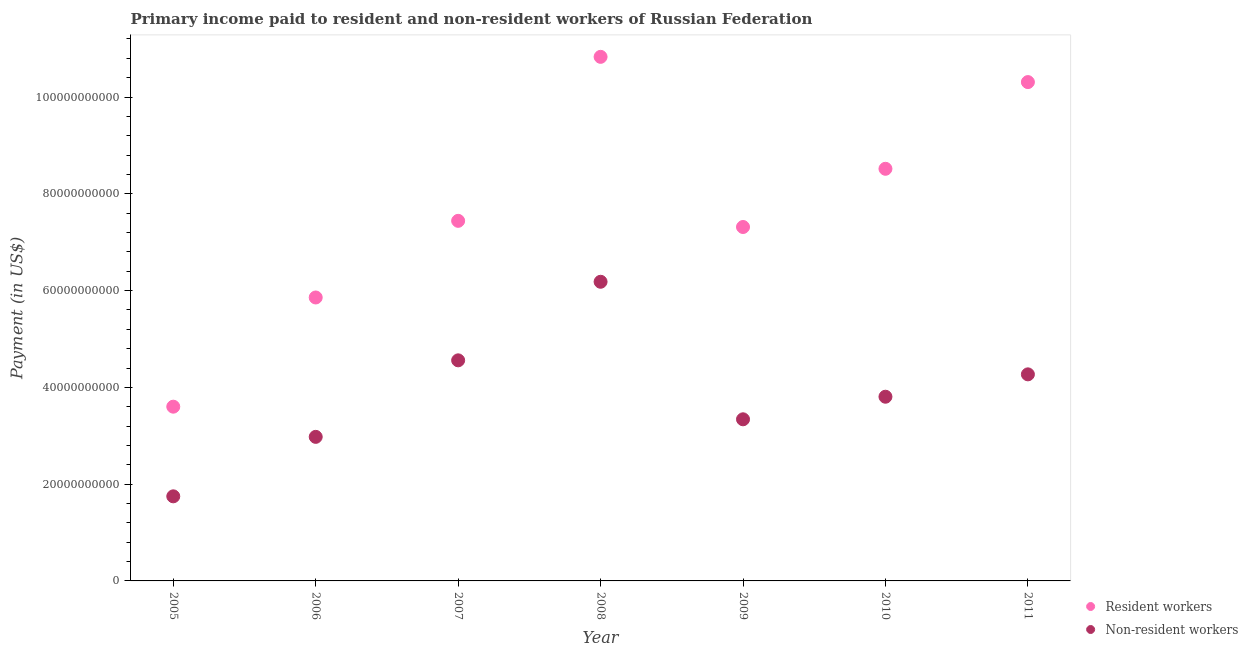Is the number of dotlines equal to the number of legend labels?
Ensure brevity in your answer.  Yes. What is the payment made to resident workers in 2011?
Keep it short and to the point. 1.03e+11. Across all years, what is the maximum payment made to resident workers?
Give a very brief answer. 1.08e+11. Across all years, what is the minimum payment made to non-resident workers?
Ensure brevity in your answer.  1.75e+1. In which year was the payment made to resident workers maximum?
Provide a short and direct response. 2008. What is the total payment made to resident workers in the graph?
Make the answer very short. 5.39e+11. What is the difference between the payment made to non-resident workers in 2006 and that in 2008?
Your answer should be compact. -3.20e+1. What is the difference between the payment made to resident workers in 2010 and the payment made to non-resident workers in 2009?
Give a very brief answer. 5.18e+1. What is the average payment made to non-resident workers per year?
Offer a very short reply. 3.84e+1. In the year 2006, what is the difference between the payment made to resident workers and payment made to non-resident workers?
Keep it short and to the point. 2.88e+1. In how many years, is the payment made to non-resident workers greater than 60000000000 US$?
Make the answer very short. 1. What is the ratio of the payment made to non-resident workers in 2008 to that in 2011?
Your response must be concise. 1.45. Is the payment made to non-resident workers in 2007 less than that in 2009?
Your answer should be compact. No. What is the difference between the highest and the second highest payment made to non-resident workers?
Make the answer very short. 1.62e+1. What is the difference between the highest and the lowest payment made to resident workers?
Offer a very short reply. 7.23e+1. Is the sum of the payment made to non-resident workers in 2010 and 2011 greater than the maximum payment made to resident workers across all years?
Make the answer very short. No. Does the payment made to non-resident workers monotonically increase over the years?
Keep it short and to the point. No. Is the payment made to resident workers strictly greater than the payment made to non-resident workers over the years?
Offer a very short reply. Yes. Are the values on the major ticks of Y-axis written in scientific E-notation?
Your answer should be very brief. No. Does the graph contain any zero values?
Make the answer very short. No. Does the graph contain grids?
Offer a very short reply. No. How are the legend labels stacked?
Provide a short and direct response. Vertical. What is the title of the graph?
Keep it short and to the point. Primary income paid to resident and non-resident workers of Russian Federation. Does "Banks" appear as one of the legend labels in the graph?
Your answer should be very brief. No. What is the label or title of the Y-axis?
Your answer should be very brief. Payment (in US$). What is the Payment (in US$) of Resident workers in 2005?
Make the answer very short. 3.60e+1. What is the Payment (in US$) of Non-resident workers in 2005?
Provide a short and direct response. 1.75e+1. What is the Payment (in US$) in Resident workers in 2006?
Make the answer very short. 5.86e+1. What is the Payment (in US$) in Non-resident workers in 2006?
Your answer should be very brief. 2.98e+1. What is the Payment (in US$) in Resident workers in 2007?
Your answer should be compact. 7.44e+1. What is the Payment (in US$) of Non-resident workers in 2007?
Offer a terse response. 4.56e+1. What is the Payment (in US$) of Resident workers in 2008?
Your answer should be compact. 1.08e+11. What is the Payment (in US$) in Non-resident workers in 2008?
Your response must be concise. 6.18e+1. What is the Payment (in US$) of Resident workers in 2009?
Keep it short and to the point. 7.31e+1. What is the Payment (in US$) in Non-resident workers in 2009?
Your answer should be compact. 3.34e+1. What is the Payment (in US$) of Resident workers in 2010?
Offer a very short reply. 8.52e+1. What is the Payment (in US$) in Non-resident workers in 2010?
Give a very brief answer. 3.81e+1. What is the Payment (in US$) of Resident workers in 2011?
Give a very brief answer. 1.03e+11. What is the Payment (in US$) of Non-resident workers in 2011?
Ensure brevity in your answer.  4.27e+1. Across all years, what is the maximum Payment (in US$) in Resident workers?
Make the answer very short. 1.08e+11. Across all years, what is the maximum Payment (in US$) in Non-resident workers?
Your answer should be compact. 6.18e+1. Across all years, what is the minimum Payment (in US$) of Resident workers?
Offer a terse response. 3.60e+1. Across all years, what is the minimum Payment (in US$) in Non-resident workers?
Your answer should be compact. 1.75e+1. What is the total Payment (in US$) in Resident workers in the graph?
Make the answer very short. 5.39e+11. What is the total Payment (in US$) of Non-resident workers in the graph?
Make the answer very short. 2.69e+11. What is the difference between the Payment (in US$) in Resident workers in 2005 and that in 2006?
Ensure brevity in your answer.  -2.26e+1. What is the difference between the Payment (in US$) in Non-resident workers in 2005 and that in 2006?
Offer a very short reply. -1.23e+1. What is the difference between the Payment (in US$) of Resident workers in 2005 and that in 2007?
Make the answer very short. -3.84e+1. What is the difference between the Payment (in US$) of Non-resident workers in 2005 and that in 2007?
Your answer should be very brief. -2.81e+1. What is the difference between the Payment (in US$) in Resident workers in 2005 and that in 2008?
Provide a succinct answer. -7.23e+1. What is the difference between the Payment (in US$) in Non-resident workers in 2005 and that in 2008?
Keep it short and to the point. -4.43e+1. What is the difference between the Payment (in US$) in Resident workers in 2005 and that in 2009?
Provide a succinct answer. -3.71e+1. What is the difference between the Payment (in US$) of Non-resident workers in 2005 and that in 2009?
Make the answer very short. -1.59e+1. What is the difference between the Payment (in US$) in Resident workers in 2005 and that in 2010?
Give a very brief answer. -4.92e+1. What is the difference between the Payment (in US$) in Non-resident workers in 2005 and that in 2010?
Your answer should be very brief. -2.06e+1. What is the difference between the Payment (in US$) of Resident workers in 2005 and that in 2011?
Provide a succinct answer. -6.71e+1. What is the difference between the Payment (in US$) of Non-resident workers in 2005 and that in 2011?
Offer a very short reply. -2.52e+1. What is the difference between the Payment (in US$) of Resident workers in 2006 and that in 2007?
Provide a succinct answer. -1.58e+1. What is the difference between the Payment (in US$) of Non-resident workers in 2006 and that in 2007?
Keep it short and to the point. -1.58e+1. What is the difference between the Payment (in US$) in Resident workers in 2006 and that in 2008?
Provide a succinct answer. -4.97e+1. What is the difference between the Payment (in US$) of Non-resident workers in 2006 and that in 2008?
Your response must be concise. -3.20e+1. What is the difference between the Payment (in US$) in Resident workers in 2006 and that in 2009?
Give a very brief answer. -1.46e+1. What is the difference between the Payment (in US$) of Non-resident workers in 2006 and that in 2009?
Ensure brevity in your answer.  -3.63e+09. What is the difference between the Payment (in US$) in Resident workers in 2006 and that in 2010?
Your response must be concise. -2.66e+1. What is the difference between the Payment (in US$) in Non-resident workers in 2006 and that in 2010?
Make the answer very short. -8.29e+09. What is the difference between the Payment (in US$) of Resident workers in 2006 and that in 2011?
Provide a succinct answer. -4.45e+1. What is the difference between the Payment (in US$) of Non-resident workers in 2006 and that in 2011?
Make the answer very short. -1.29e+1. What is the difference between the Payment (in US$) in Resident workers in 2007 and that in 2008?
Your answer should be compact. -3.39e+1. What is the difference between the Payment (in US$) in Non-resident workers in 2007 and that in 2008?
Keep it short and to the point. -1.62e+1. What is the difference between the Payment (in US$) in Resident workers in 2007 and that in 2009?
Offer a very short reply. 1.27e+09. What is the difference between the Payment (in US$) of Non-resident workers in 2007 and that in 2009?
Provide a short and direct response. 1.22e+1. What is the difference between the Payment (in US$) of Resident workers in 2007 and that in 2010?
Offer a terse response. -1.08e+1. What is the difference between the Payment (in US$) of Non-resident workers in 2007 and that in 2010?
Your answer should be very brief. 7.52e+09. What is the difference between the Payment (in US$) of Resident workers in 2007 and that in 2011?
Keep it short and to the point. -2.87e+1. What is the difference between the Payment (in US$) in Non-resident workers in 2007 and that in 2011?
Provide a succinct answer. 2.90e+09. What is the difference between the Payment (in US$) of Resident workers in 2008 and that in 2009?
Ensure brevity in your answer.  3.52e+1. What is the difference between the Payment (in US$) of Non-resident workers in 2008 and that in 2009?
Ensure brevity in your answer.  2.84e+1. What is the difference between the Payment (in US$) in Resident workers in 2008 and that in 2010?
Make the answer very short. 2.31e+1. What is the difference between the Payment (in US$) in Non-resident workers in 2008 and that in 2010?
Offer a terse response. 2.38e+1. What is the difference between the Payment (in US$) of Resident workers in 2008 and that in 2011?
Provide a succinct answer. 5.22e+09. What is the difference between the Payment (in US$) of Non-resident workers in 2008 and that in 2011?
Make the answer very short. 1.91e+1. What is the difference between the Payment (in US$) of Resident workers in 2009 and that in 2010?
Your answer should be very brief. -1.20e+1. What is the difference between the Payment (in US$) of Non-resident workers in 2009 and that in 2010?
Provide a short and direct response. -4.66e+09. What is the difference between the Payment (in US$) of Resident workers in 2009 and that in 2011?
Provide a succinct answer. -2.99e+1. What is the difference between the Payment (in US$) of Non-resident workers in 2009 and that in 2011?
Provide a succinct answer. -9.29e+09. What is the difference between the Payment (in US$) of Resident workers in 2010 and that in 2011?
Provide a succinct answer. -1.79e+1. What is the difference between the Payment (in US$) of Non-resident workers in 2010 and that in 2011?
Give a very brief answer. -4.62e+09. What is the difference between the Payment (in US$) of Resident workers in 2005 and the Payment (in US$) of Non-resident workers in 2006?
Your answer should be compact. 6.24e+09. What is the difference between the Payment (in US$) of Resident workers in 2005 and the Payment (in US$) of Non-resident workers in 2007?
Provide a short and direct response. -9.58e+09. What is the difference between the Payment (in US$) of Resident workers in 2005 and the Payment (in US$) of Non-resident workers in 2008?
Offer a terse response. -2.58e+1. What is the difference between the Payment (in US$) in Resident workers in 2005 and the Payment (in US$) in Non-resident workers in 2009?
Give a very brief answer. 2.61e+09. What is the difference between the Payment (in US$) of Resident workers in 2005 and the Payment (in US$) of Non-resident workers in 2010?
Give a very brief answer. -2.06e+09. What is the difference between the Payment (in US$) of Resident workers in 2005 and the Payment (in US$) of Non-resident workers in 2011?
Make the answer very short. -6.68e+09. What is the difference between the Payment (in US$) of Resident workers in 2006 and the Payment (in US$) of Non-resident workers in 2007?
Make the answer very short. 1.30e+1. What is the difference between the Payment (in US$) in Resident workers in 2006 and the Payment (in US$) in Non-resident workers in 2008?
Offer a terse response. -3.25e+09. What is the difference between the Payment (in US$) of Resident workers in 2006 and the Payment (in US$) of Non-resident workers in 2009?
Your answer should be very brief. 2.52e+1. What is the difference between the Payment (in US$) of Resident workers in 2006 and the Payment (in US$) of Non-resident workers in 2010?
Your response must be concise. 2.05e+1. What is the difference between the Payment (in US$) of Resident workers in 2006 and the Payment (in US$) of Non-resident workers in 2011?
Give a very brief answer. 1.59e+1. What is the difference between the Payment (in US$) in Resident workers in 2007 and the Payment (in US$) in Non-resident workers in 2008?
Provide a succinct answer. 1.26e+1. What is the difference between the Payment (in US$) of Resident workers in 2007 and the Payment (in US$) of Non-resident workers in 2009?
Offer a very short reply. 4.10e+1. What is the difference between the Payment (in US$) in Resident workers in 2007 and the Payment (in US$) in Non-resident workers in 2010?
Ensure brevity in your answer.  3.63e+1. What is the difference between the Payment (in US$) of Resident workers in 2007 and the Payment (in US$) of Non-resident workers in 2011?
Your answer should be compact. 3.17e+1. What is the difference between the Payment (in US$) in Resident workers in 2008 and the Payment (in US$) in Non-resident workers in 2009?
Offer a very short reply. 7.49e+1. What is the difference between the Payment (in US$) in Resident workers in 2008 and the Payment (in US$) in Non-resident workers in 2010?
Provide a succinct answer. 7.02e+1. What is the difference between the Payment (in US$) in Resident workers in 2008 and the Payment (in US$) in Non-resident workers in 2011?
Offer a very short reply. 6.56e+1. What is the difference between the Payment (in US$) of Resident workers in 2009 and the Payment (in US$) of Non-resident workers in 2010?
Your response must be concise. 3.51e+1. What is the difference between the Payment (in US$) of Resident workers in 2009 and the Payment (in US$) of Non-resident workers in 2011?
Keep it short and to the point. 3.05e+1. What is the difference between the Payment (in US$) in Resident workers in 2010 and the Payment (in US$) in Non-resident workers in 2011?
Your response must be concise. 4.25e+1. What is the average Payment (in US$) in Resident workers per year?
Keep it short and to the point. 7.70e+1. What is the average Payment (in US$) of Non-resident workers per year?
Provide a succinct answer. 3.84e+1. In the year 2005, what is the difference between the Payment (in US$) in Resident workers and Payment (in US$) in Non-resident workers?
Your response must be concise. 1.85e+1. In the year 2006, what is the difference between the Payment (in US$) of Resident workers and Payment (in US$) of Non-resident workers?
Offer a terse response. 2.88e+1. In the year 2007, what is the difference between the Payment (in US$) of Resident workers and Payment (in US$) of Non-resident workers?
Offer a very short reply. 2.88e+1. In the year 2008, what is the difference between the Payment (in US$) in Resident workers and Payment (in US$) in Non-resident workers?
Offer a terse response. 4.65e+1. In the year 2009, what is the difference between the Payment (in US$) of Resident workers and Payment (in US$) of Non-resident workers?
Keep it short and to the point. 3.97e+1. In the year 2010, what is the difference between the Payment (in US$) in Resident workers and Payment (in US$) in Non-resident workers?
Your response must be concise. 4.71e+1. In the year 2011, what is the difference between the Payment (in US$) in Resident workers and Payment (in US$) in Non-resident workers?
Give a very brief answer. 6.04e+1. What is the ratio of the Payment (in US$) of Resident workers in 2005 to that in 2006?
Provide a short and direct response. 0.61. What is the ratio of the Payment (in US$) in Non-resident workers in 2005 to that in 2006?
Ensure brevity in your answer.  0.59. What is the ratio of the Payment (in US$) in Resident workers in 2005 to that in 2007?
Keep it short and to the point. 0.48. What is the ratio of the Payment (in US$) of Non-resident workers in 2005 to that in 2007?
Give a very brief answer. 0.38. What is the ratio of the Payment (in US$) in Resident workers in 2005 to that in 2008?
Give a very brief answer. 0.33. What is the ratio of the Payment (in US$) in Non-resident workers in 2005 to that in 2008?
Make the answer very short. 0.28. What is the ratio of the Payment (in US$) in Resident workers in 2005 to that in 2009?
Offer a terse response. 0.49. What is the ratio of the Payment (in US$) of Non-resident workers in 2005 to that in 2009?
Your response must be concise. 0.52. What is the ratio of the Payment (in US$) in Resident workers in 2005 to that in 2010?
Keep it short and to the point. 0.42. What is the ratio of the Payment (in US$) of Non-resident workers in 2005 to that in 2010?
Provide a short and direct response. 0.46. What is the ratio of the Payment (in US$) in Resident workers in 2005 to that in 2011?
Keep it short and to the point. 0.35. What is the ratio of the Payment (in US$) of Non-resident workers in 2005 to that in 2011?
Your answer should be very brief. 0.41. What is the ratio of the Payment (in US$) of Resident workers in 2006 to that in 2007?
Your response must be concise. 0.79. What is the ratio of the Payment (in US$) in Non-resident workers in 2006 to that in 2007?
Your answer should be compact. 0.65. What is the ratio of the Payment (in US$) of Resident workers in 2006 to that in 2008?
Your answer should be very brief. 0.54. What is the ratio of the Payment (in US$) of Non-resident workers in 2006 to that in 2008?
Make the answer very short. 0.48. What is the ratio of the Payment (in US$) in Resident workers in 2006 to that in 2009?
Your answer should be very brief. 0.8. What is the ratio of the Payment (in US$) in Non-resident workers in 2006 to that in 2009?
Your response must be concise. 0.89. What is the ratio of the Payment (in US$) of Resident workers in 2006 to that in 2010?
Make the answer very short. 0.69. What is the ratio of the Payment (in US$) of Non-resident workers in 2006 to that in 2010?
Give a very brief answer. 0.78. What is the ratio of the Payment (in US$) of Resident workers in 2006 to that in 2011?
Your answer should be compact. 0.57. What is the ratio of the Payment (in US$) of Non-resident workers in 2006 to that in 2011?
Provide a succinct answer. 0.7. What is the ratio of the Payment (in US$) of Resident workers in 2007 to that in 2008?
Make the answer very short. 0.69. What is the ratio of the Payment (in US$) of Non-resident workers in 2007 to that in 2008?
Provide a succinct answer. 0.74. What is the ratio of the Payment (in US$) of Resident workers in 2007 to that in 2009?
Your answer should be very brief. 1.02. What is the ratio of the Payment (in US$) of Non-resident workers in 2007 to that in 2009?
Ensure brevity in your answer.  1.36. What is the ratio of the Payment (in US$) of Resident workers in 2007 to that in 2010?
Provide a succinct answer. 0.87. What is the ratio of the Payment (in US$) of Non-resident workers in 2007 to that in 2010?
Offer a terse response. 1.2. What is the ratio of the Payment (in US$) in Resident workers in 2007 to that in 2011?
Your response must be concise. 0.72. What is the ratio of the Payment (in US$) in Non-resident workers in 2007 to that in 2011?
Make the answer very short. 1.07. What is the ratio of the Payment (in US$) of Resident workers in 2008 to that in 2009?
Make the answer very short. 1.48. What is the ratio of the Payment (in US$) in Non-resident workers in 2008 to that in 2009?
Offer a very short reply. 1.85. What is the ratio of the Payment (in US$) of Resident workers in 2008 to that in 2010?
Offer a very short reply. 1.27. What is the ratio of the Payment (in US$) of Non-resident workers in 2008 to that in 2010?
Your answer should be compact. 1.62. What is the ratio of the Payment (in US$) in Resident workers in 2008 to that in 2011?
Provide a short and direct response. 1.05. What is the ratio of the Payment (in US$) in Non-resident workers in 2008 to that in 2011?
Keep it short and to the point. 1.45. What is the ratio of the Payment (in US$) of Resident workers in 2009 to that in 2010?
Provide a short and direct response. 0.86. What is the ratio of the Payment (in US$) in Non-resident workers in 2009 to that in 2010?
Provide a short and direct response. 0.88. What is the ratio of the Payment (in US$) in Resident workers in 2009 to that in 2011?
Your answer should be very brief. 0.71. What is the ratio of the Payment (in US$) in Non-resident workers in 2009 to that in 2011?
Make the answer very short. 0.78. What is the ratio of the Payment (in US$) of Resident workers in 2010 to that in 2011?
Your answer should be compact. 0.83. What is the ratio of the Payment (in US$) of Non-resident workers in 2010 to that in 2011?
Provide a short and direct response. 0.89. What is the difference between the highest and the second highest Payment (in US$) in Resident workers?
Give a very brief answer. 5.22e+09. What is the difference between the highest and the second highest Payment (in US$) of Non-resident workers?
Your answer should be compact. 1.62e+1. What is the difference between the highest and the lowest Payment (in US$) of Resident workers?
Your response must be concise. 7.23e+1. What is the difference between the highest and the lowest Payment (in US$) in Non-resident workers?
Make the answer very short. 4.43e+1. 